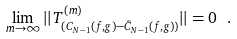<formula> <loc_0><loc_0><loc_500><loc_500>\lim _ { m \to \infty } | | T ^ { ( m ) } _ { ( C _ { N - 1 } ( f , g ) - \tilde { C } _ { N - 1 } ( f , g ) ) } | | = 0 \ .</formula> 